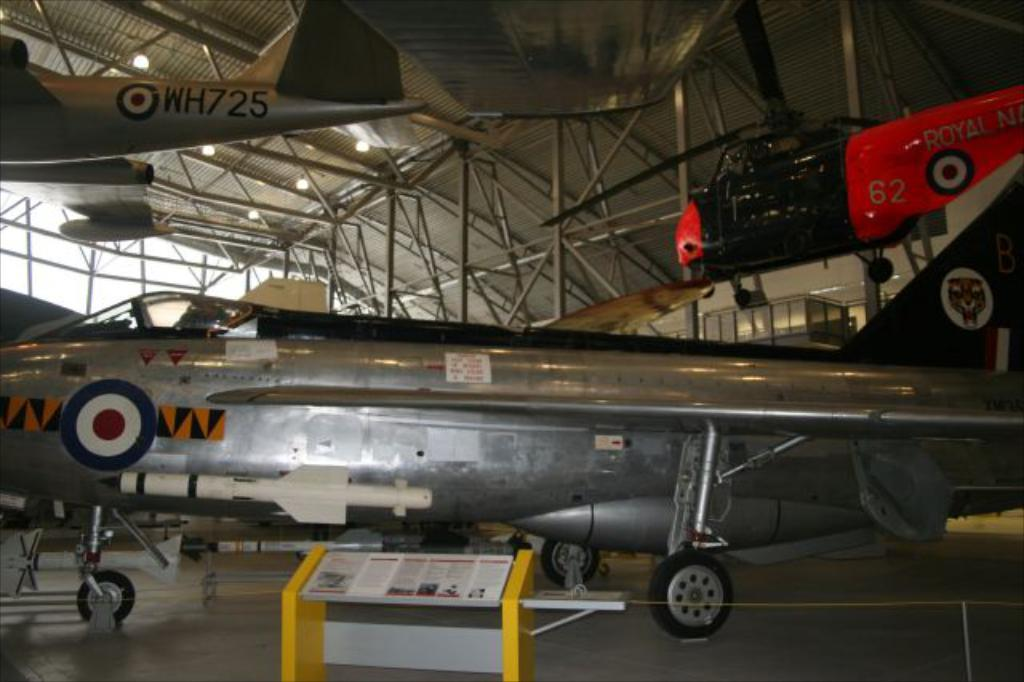<image>
Offer a succinct explanation of the picture presented. the number 62 is on the side of a plane 